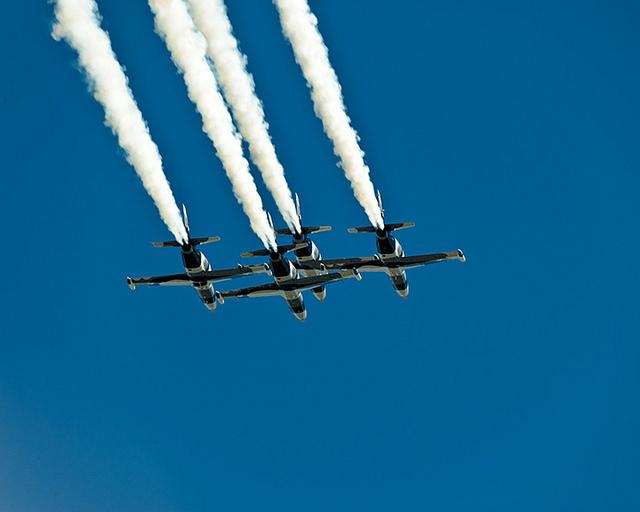How many jet planes are flying together in the sky with military formation?

Choices:
A) one
B) three
C) two
D) four four 